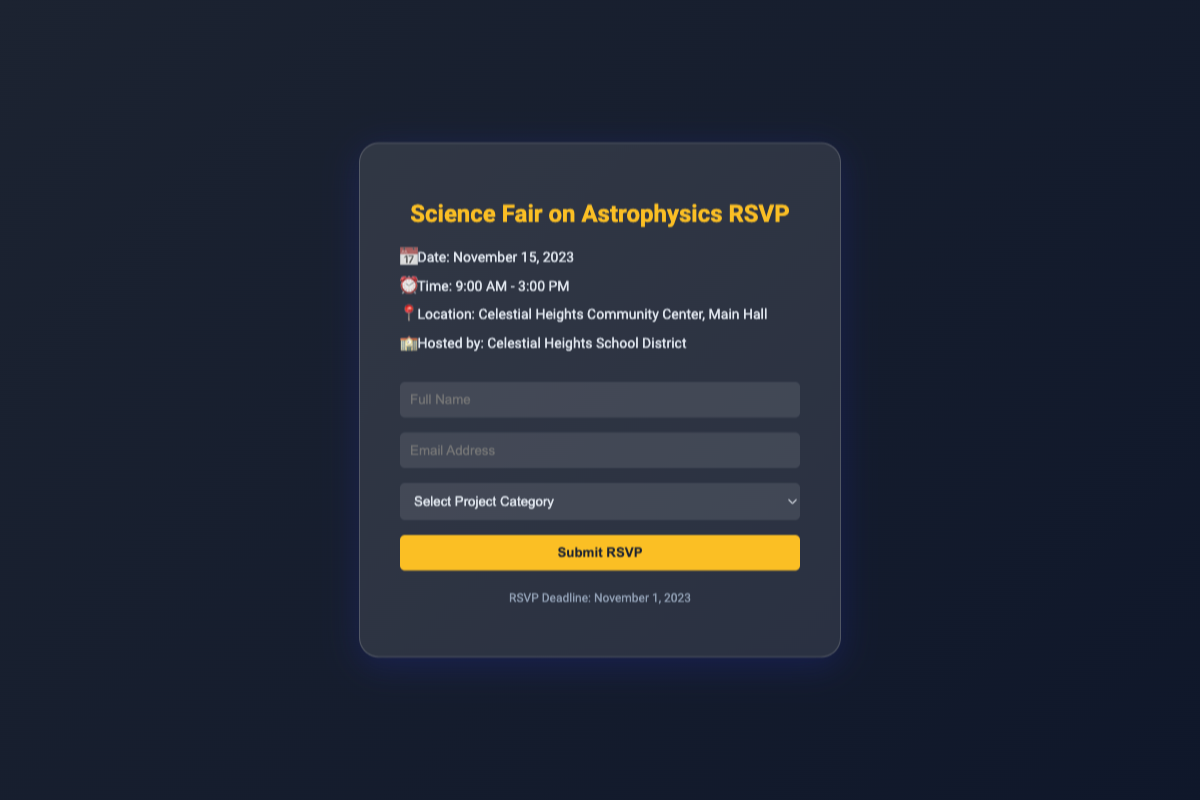what is the date of the event? The date of the event is specified in the document, which states it as November 15, 2023.
Answer: November 15, 2023 what time does the event start? The start time of the event is provided in the document, indicating it begins at 9:00 AM.
Answer: 9:00 AM where is the event being held? The location of the event is mentioned in the document, specifically at Celestial Heights Community Center, Main Hall.
Answer: Celestial Heights Community Center, Main Hall who is hosting the event? The document specifies the host of the event as Celestial Heights School District.
Answer: Celestial Heights School District what is the RSVP deadline? The RSVP deadline is clearly stated in the document as November 1, 2023.
Answer: November 1, 2023 how many project categories are listed? The document lists five different project categories for participants to choose from.
Answer: Five what are the project categories? The project categories described in the document include Observational Astronomy, Theoretical Astrophysics, Astrochemistry, Astrobiology, and Space Technology.
Answer: Observational Astronomy, Theoretical Astrophysics, Astrochemistry, Astrobiology, Space Technology what type of form is included in the document? The document features an RSVP form that requires specific participant information.
Answer: RSVP form what is required to submit the RSVP? The RSVP form requires the participant's full name, email address, and selection of a project category to be submitted.
Answer: Full name, email address, project category selection 